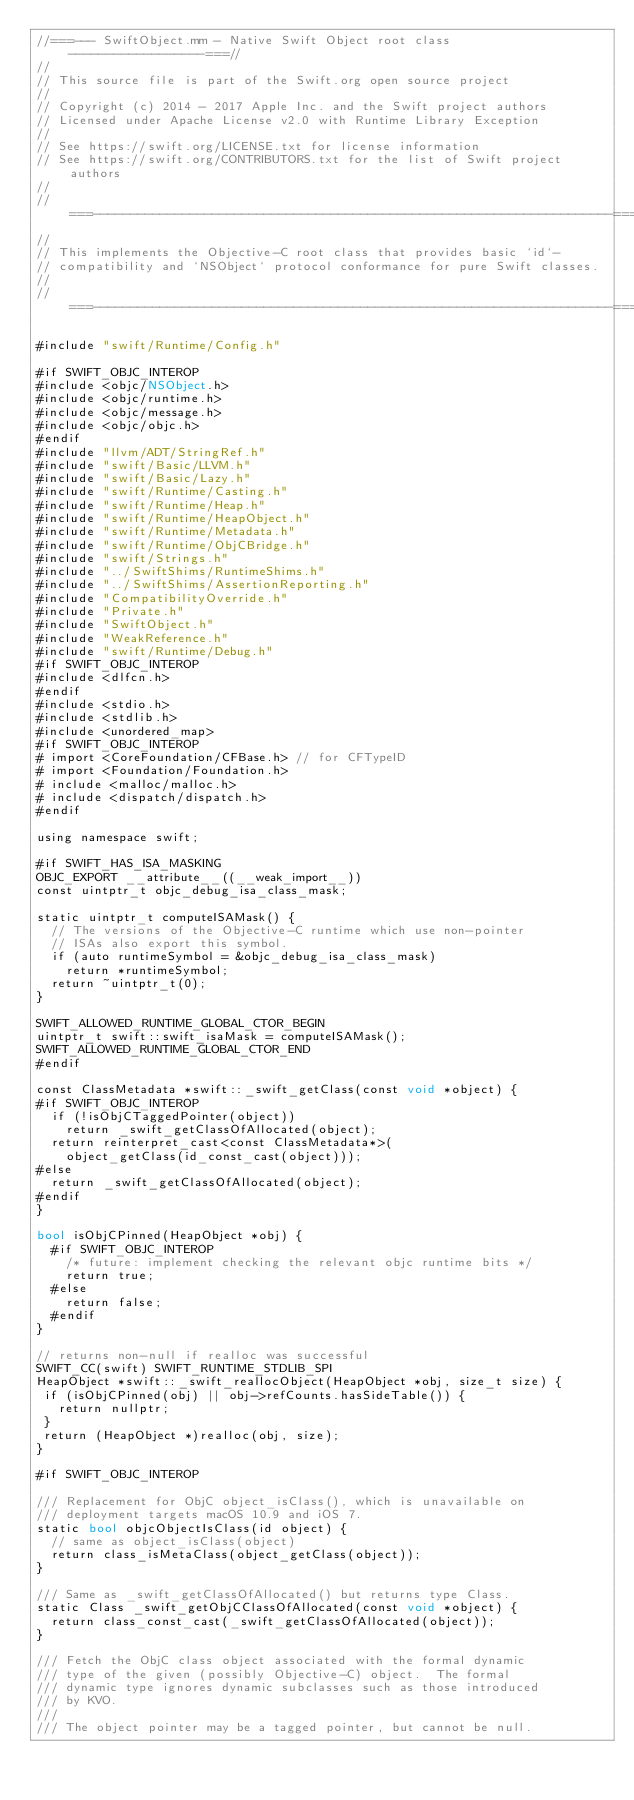Convert code to text. <code><loc_0><loc_0><loc_500><loc_500><_ObjectiveC_>//===--- SwiftObject.mm - Native Swift Object root class ------------------===//
//
// This source file is part of the Swift.org open source project
//
// Copyright (c) 2014 - 2017 Apple Inc. and the Swift project authors
// Licensed under Apache License v2.0 with Runtime Library Exception
//
// See https://swift.org/LICENSE.txt for license information
// See https://swift.org/CONTRIBUTORS.txt for the list of Swift project authors
//
//===----------------------------------------------------------------------===//
//
// This implements the Objective-C root class that provides basic `id`-
// compatibility and `NSObject` protocol conformance for pure Swift classes.
//
//===----------------------------------------------------------------------===//

#include "swift/Runtime/Config.h"

#if SWIFT_OBJC_INTEROP
#include <objc/NSObject.h>
#include <objc/runtime.h>
#include <objc/message.h>
#include <objc/objc.h>
#endif
#include "llvm/ADT/StringRef.h"
#include "swift/Basic/LLVM.h"
#include "swift/Basic/Lazy.h"
#include "swift/Runtime/Casting.h"
#include "swift/Runtime/Heap.h"
#include "swift/Runtime/HeapObject.h"
#include "swift/Runtime/Metadata.h"
#include "swift/Runtime/ObjCBridge.h"
#include "swift/Strings.h"
#include "../SwiftShims/RuntimeShims.h"
#include "../SwiftShims/AssertionReporting.h"
#include "CompatibilityOverride.h"
#include "Private.h"
#include "SwiftObject.h"
#include "WeakReference.h"
#include "swift/Runtime/Debug.h"
#if SWIFT_OBJC_INTEROP
#include <dlfcn.h>
#endif
#include <stdio.h>
#include <stdlib.h>
#include <unordered_map>
#if SWIFT_OBJC_INTEROP
# import <CoreFoundation/CFBase.h> // for CFTypeID
# import <Foundation/Foundation.h>
# include <malloc/malloc.h>
# include <dispatch/dispatch.h>
#endif

using namespace swift;

#if SWIFT_HAS_ISA_MASKING
OBJC_EXPORT __attribute__((__weak_import__))
const uintptr_t objc_debug_isa_class_mask;

static uintptr_t computeISAMask() {
  // The versions of the Objective-C runtime which use non-pointer
  // ISAs also export this symbol.
  if (auto runtimeSymbol = &objc_debug_isa_class_mask)
    return *runtimeSymbol;
  return ~uintptr_t(0);
}

SWIFT_ALLOWED_RUNTIME_GLOBAL_CTOR_BEGIN
uintptr_t swift::swift_isaMask = computeISAMask();
SWIFT_ALLOWED_RUNTIME_GLOBAL_CTOR_END
#endif

const ClassMetadata *swift::_swift_getClass(const void *object) {
#if SWIFT_OBJC_INTEROP
  if (!isObjCTaggedPointer(object))
    return _swift_getClassOfAllocated(object);
  return reinterpret_cast<const ClassMetadata*>(
    object_getClass(id_const_cast(object)));
#else
  return _swift_getClassOfAllocated(object);
#endif
}

bool isObjCPinned(HeapObject *obj) {
  #if SWIFT_OBJC_INTEROP
    /* future: implement checking the relevant objc runtime bits */
    return true;
  #else
    return false;
  #endif
}

// returns non-null if realloc was successful
SWIFT_CC(swift) SWIFT_RUNTIME_STDLIB_SPI
HeapObject *swift::_swift_reallocObject(HeapObject *obj, size_t size) {
 if (isObjCPinned(obj) || obj->refCounts.hasSideTable()) {
   return nullptr;
 }
 return (HeapObject *)realloc(obj, size);
}

#if SWIFT_OBJC_INTEROP

/// Replacement for ObjC object_isClass(), which is unavailable on
/// deployment targets macOS 10.9 and iOS 7.
static bool objcObjectIsClass(id object) {
  // same as object_isClass(object)
  return class_isMetaClass(object_getClass(object));
}

/// Same as _swift_getClassOfAllocated() but returns type Class.
static Class _swift_getObjCClassOfAllocated(const void *object) {
  return class_const_cast(_swift_getClassOfAllocated(object));
}

/// Fetch the ObjC class object associated with the formal dynamic
/// type of the given (possibly Objective-C) object.  The formal
/// dynamic type ignores dynamic subclasses such as those introduced
/// by KVO.
///
/// The object pointer may be a tagged pointer, but cannot be null.</code> 